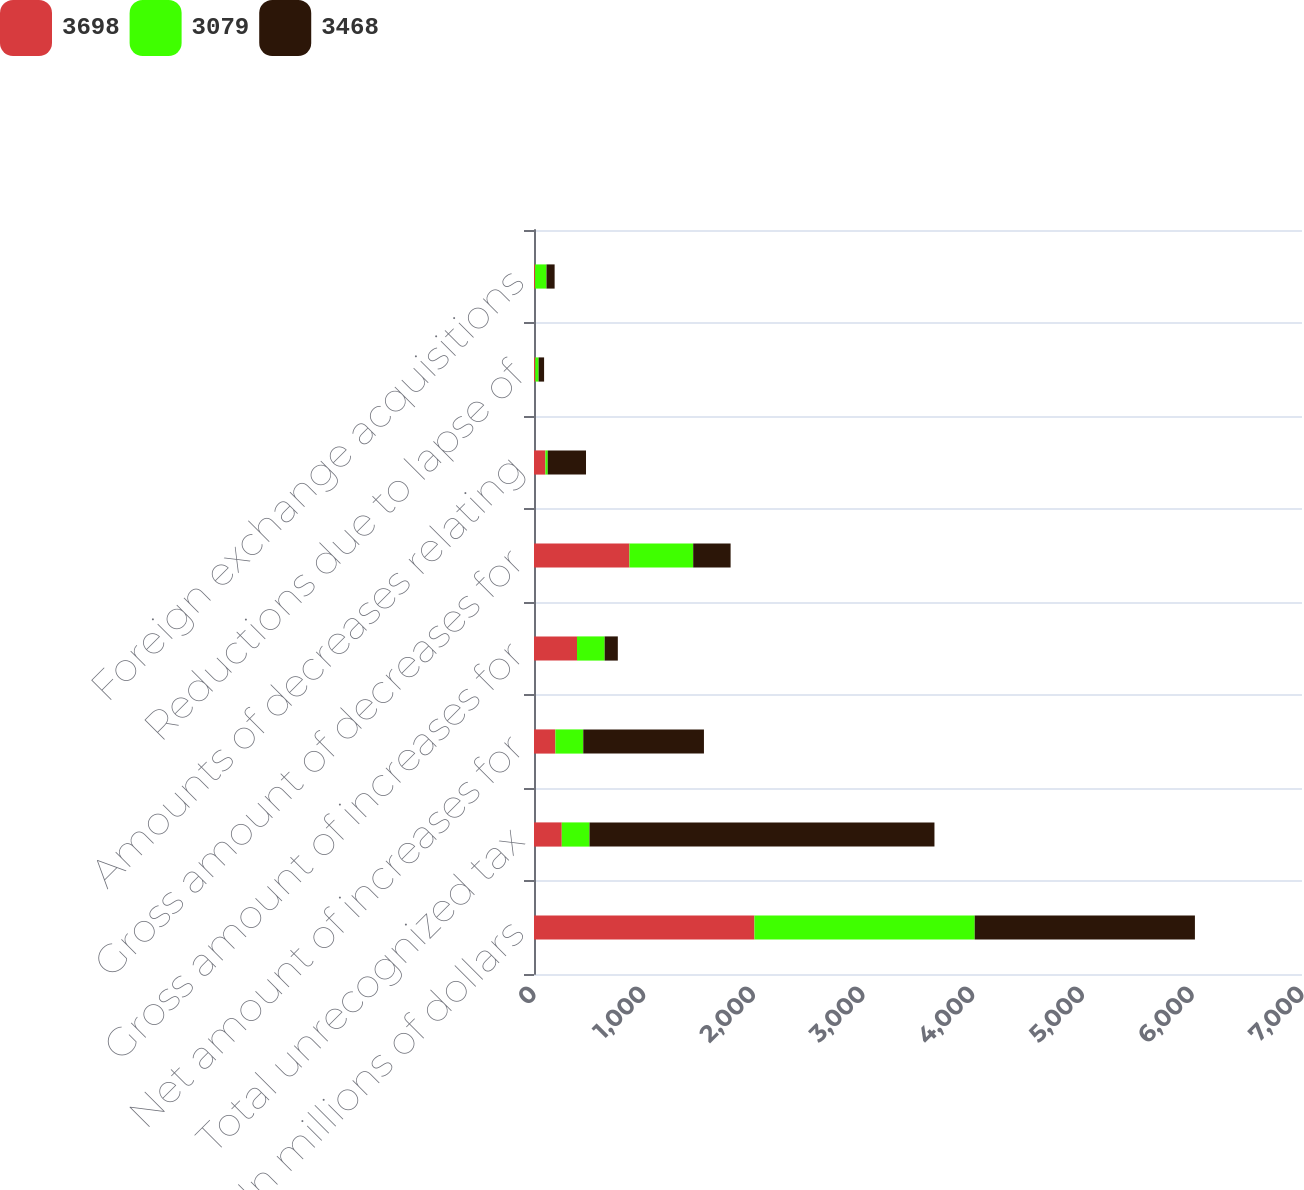Convert chart. <chart><loc_0><loc_0><loc_500><loc_500><stacked_bar_chart><ecel><fcel>In millions of dollars<fcel>Total unrecognized tax<fcel>Net amount of increases for<fcel>Gross amount of increases for<fcel>Gross amount of decreases for<fcel>Amounts of decreases relating<fcel>Reductions due to lapse of<fcel>Foreign exchange acquisitions<nl><fcel>3698<fcel>2009<fcel>253<fcel>195<fcel>392<fcel>870<fcel>104<fcel>12<fcel>10<nl><fcel>3079<fcel>2008<fcel>253<fcel>254<fcel>252<fcel>581<fcel>21<fcel>30<fcel>104<nl><fcel>3468<fcel>2007<fcel>3144<fcel>1100<fcel>120<fcel>341<fcel>349<fcel>50<fcel>74<nl></chart> 